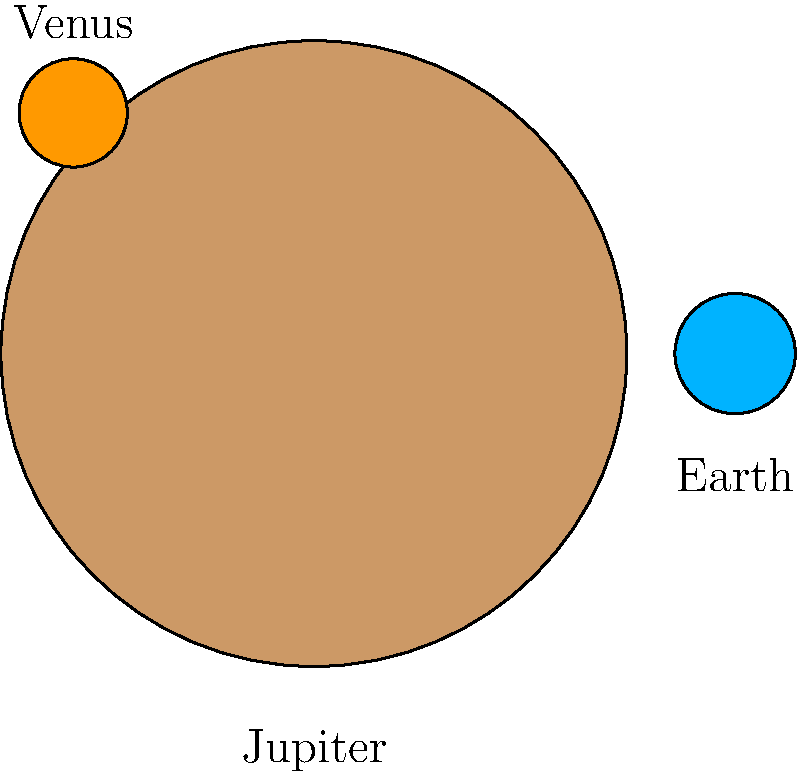In your boxing ring of planetary knowledge, which celestial heavyweight packs the biggest punch in terms of size compared to Earth? Let's break this down step-by-step, just like we'd analyze a boxing match:

1. We have three planets represented in the image: Jupiter, Earth, and Venus.

2. The sizes of the circles represent the relative sizes of the planets.

3. Earth is our reference point, as we're most familiar with its size.

4. Comparing the circles:
   - Jupiter's circle is much larger than Earth's
   - Venus's circle is slightly smaller than Earth's

5. In reality:
   - Jupiter's diameter is about 11.2 times that of Earth
   - Venus's diameter is about 0.95 times that of Earth

6. Just like in boxing, where a heavyweight outclasses smaller weight divisions, Jupiter is the clear "heavyweight champion" in terms of size.

Therefore, among the planets shown, Jupiter is significantly larger than Earth and Venus, making it the "celestial heavyweight" in this cosmic ring.
Answer: Jupiter 